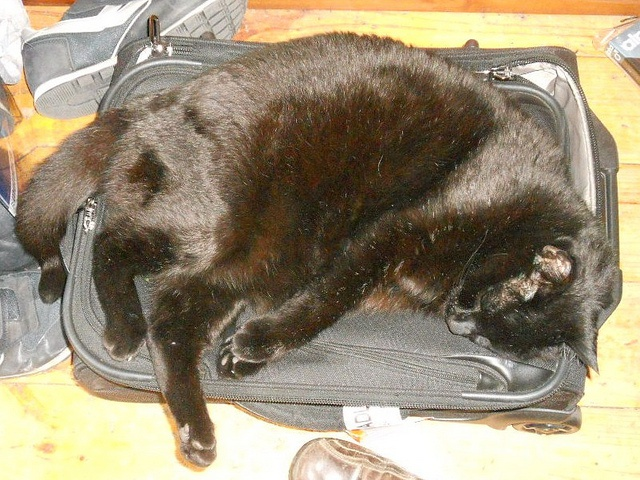Describe the objects in this image and their specific colors. I can see cat in white, black, and gray tones, suitcase in white, darkgray, gray, and lightgray tones, and book in white, lightgray, gray, tan, and darkgray tones in this image. 